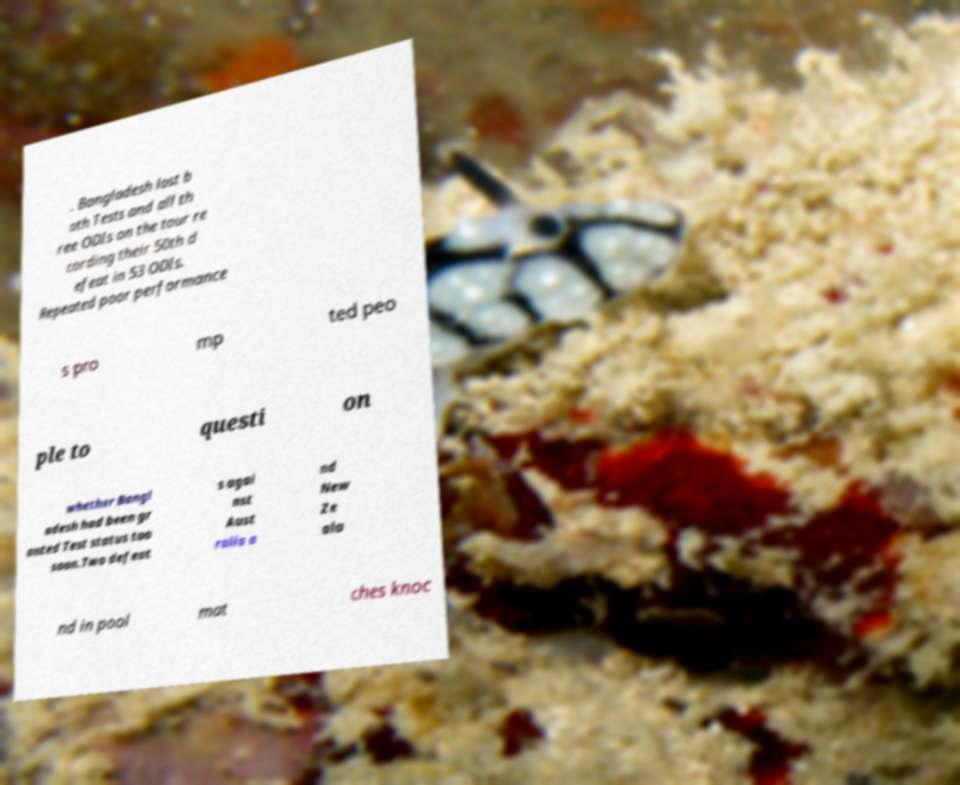Please identify and transcribe the text found in this image. . Bangladesh lost b oth Tests and all th ree ODIs on the tour re cording their 50th d efeat in 53 ODIs. Repeated poor performance s pro mp ted peo ple to questi on whether Bangl adesh had been gr anted Test status too soon.Two defeat s agai nst Aust ralia a nd New Ze ala nd in pool mat ches knoc 